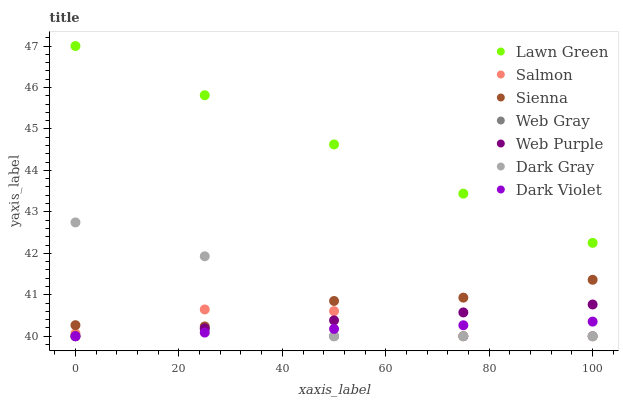Does Web Gray have the minimum area under the curve?
Answer yes or no. Yes. Does Lawn Green have the maximum area under the curve?
Answer yes or no. Yes. Does Salmon have the minimum area under the curve?
Answer yes or no. No. Does Salmon have the maximum area under the curve?
Answer yes or no. No. Is Dark Violet the smoothest?
Answer yes or no. Yes. Is Dark Gray the roughest?
Answer yes or no. Yes. Is Web Gray the smoothest?
Answer yes or no. No. Is Web Gray the roughest?
Answer yes or no. No. Does Web Gray have the lowest value?
Answer yes or no. Yes. Does Sienna have the lowest value?
Answer yes or no. No. Does Lawn Green have the highest value?
Answer yes or no. Yes. Does Salmon have the highest value?
Answer yes or no. No. Is Web Gray less than Sienna?
Answer yes or no. Yes. Is Sienna greater than Web Purple?
Answer yes or no. Yes. Does Dark Gray intersect Dark Violet?
Answer yes or no. Yes. Is Dark Gray less than Dark Violet?
Answer yes or no. No. Is Dark Gray greater than Dark Violet?
Answer yes or no. No. Does Web Gray intersect Sienna?
Answer yes or no. No. 